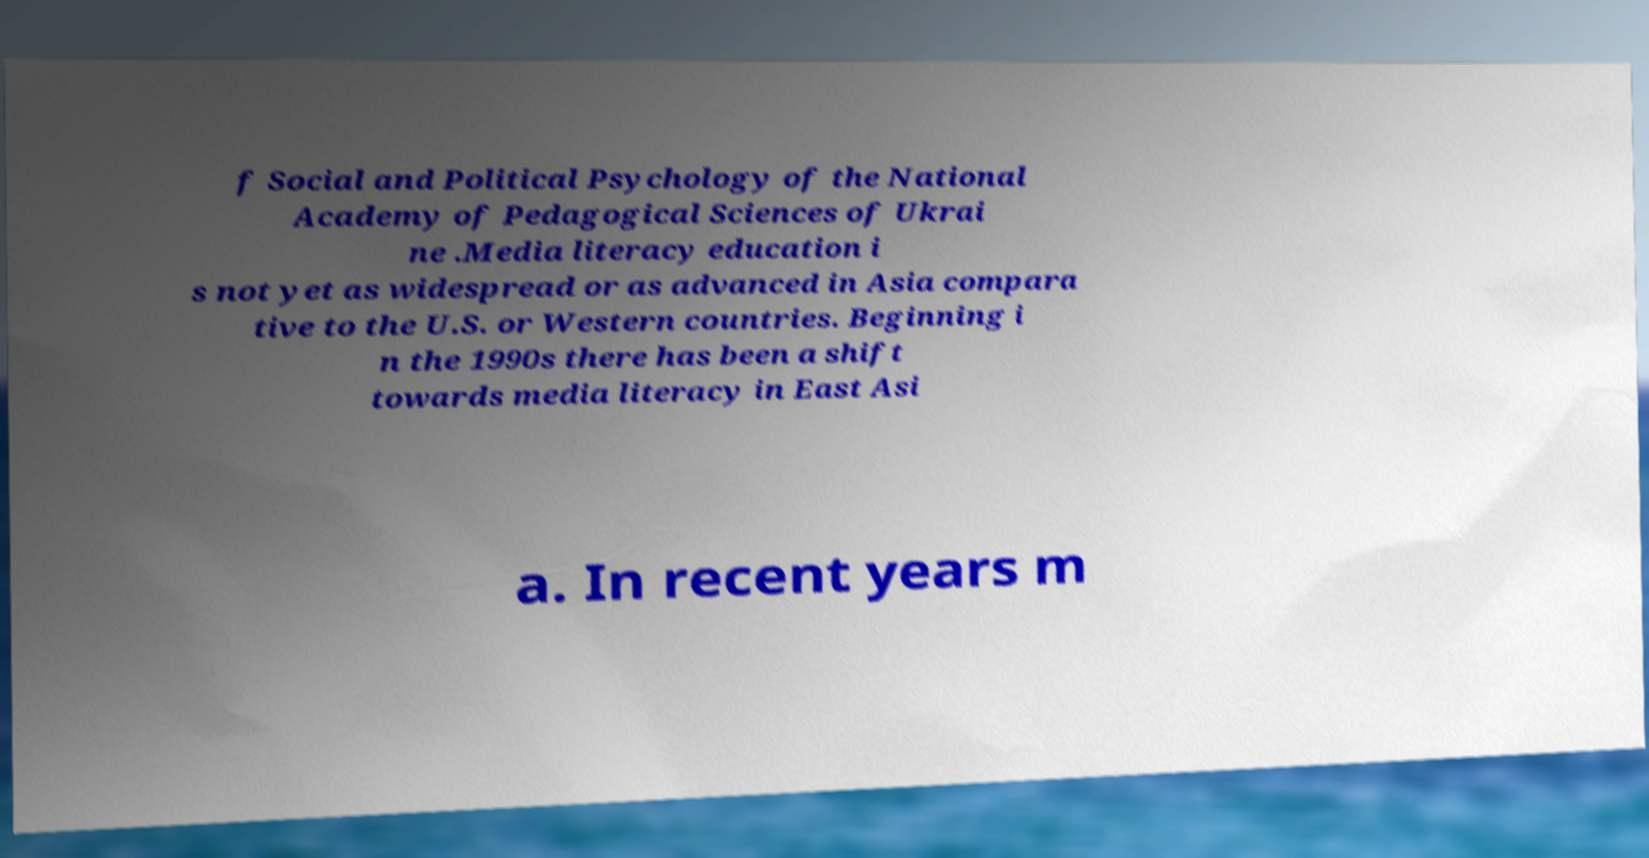There's text embedded in this image that I need extracted. Can you transcribe it verbatim? f Social and Political Psychology of the National Academy of Pedagogical Sciences of Ukrai ne .Media literacy education i s not yet as widespread or as advanced in Asia compara tive to the U.S. or Western countries. Beginning i n the 1990s there has been a shift towards media literacy in East Asi a. In recent years m 